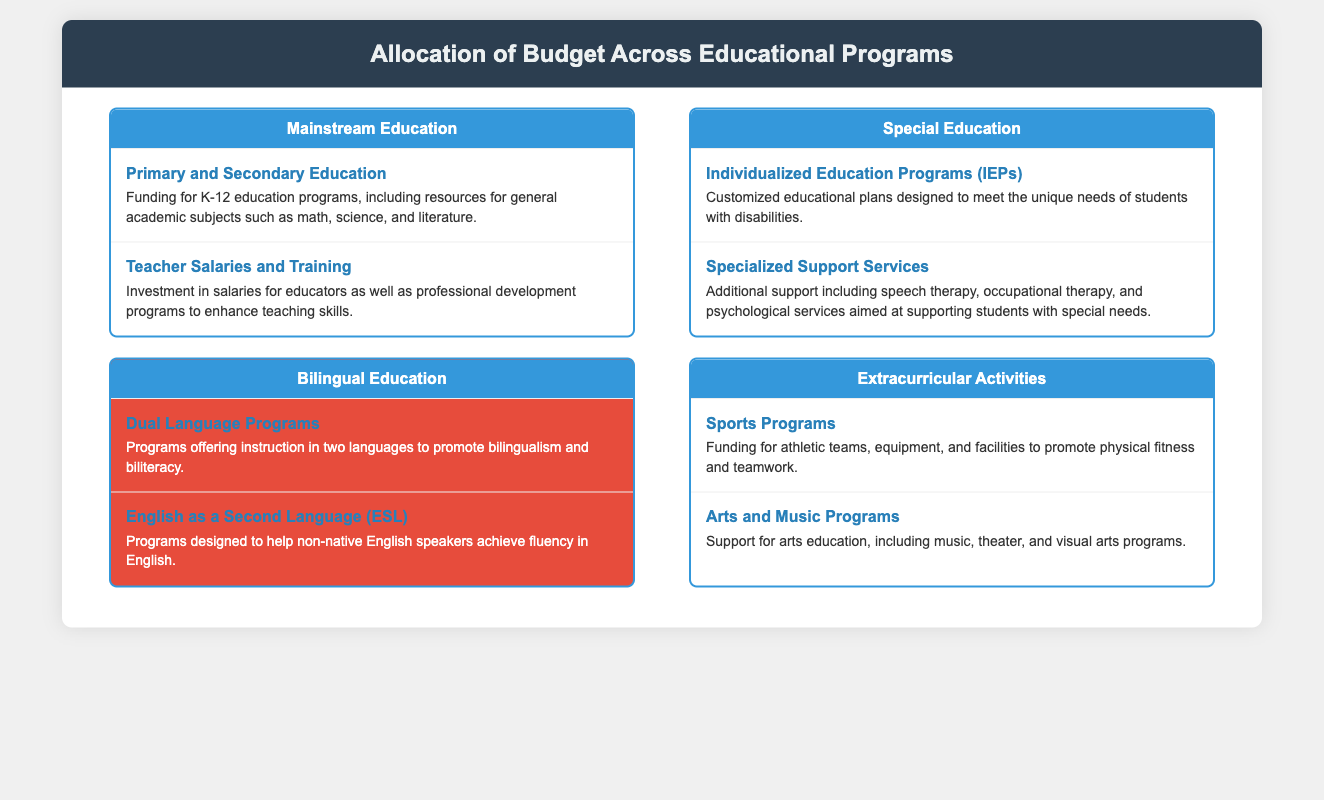What is the focus of the Bilingual Education category? The Bilingual Education category focuses on programs that promote bilingualism and biliteracy through dual language instruction.
Answer: Dual Language Programs What type of funding is allocated for K-12 education programs? The document specifies funding for general academic subjects, which includes K-12 education programs.
Answer: Primary and Secondary Education What specialized services are provided under Special Education? The document lists speech therapy and occupational therapy as part of the specialized support services provided to students with special needs.
Answer: Specialized Support Services How many entities are listed under Extracurricular Activities? The Extracurricular Activities category contains two entities, sports programs, and arts and music programs.
Answer: Two What is the goal of the English as a Second Language (ESL) programs? The ESL programs are designed to help non-native English speakers achieve fluency in English.
Answer: Achieve fluency in English Which educational program category has a highlight designation? The highlight designation is given to the Bilingual Education category in the infographic, signifying its importance.
Answer: Bilingual Education What type of instruction is offered in Dual Language Programs? The document explains that Dual Language Programs offer instruction in two languages.
Answer: Two languages What is emphasized in the document regarding Teacher Salaries and Training? The emphasis is on investment for educator salaries and professional development programs to enhance teaching skills.
Answer: Investment in salaries and training 